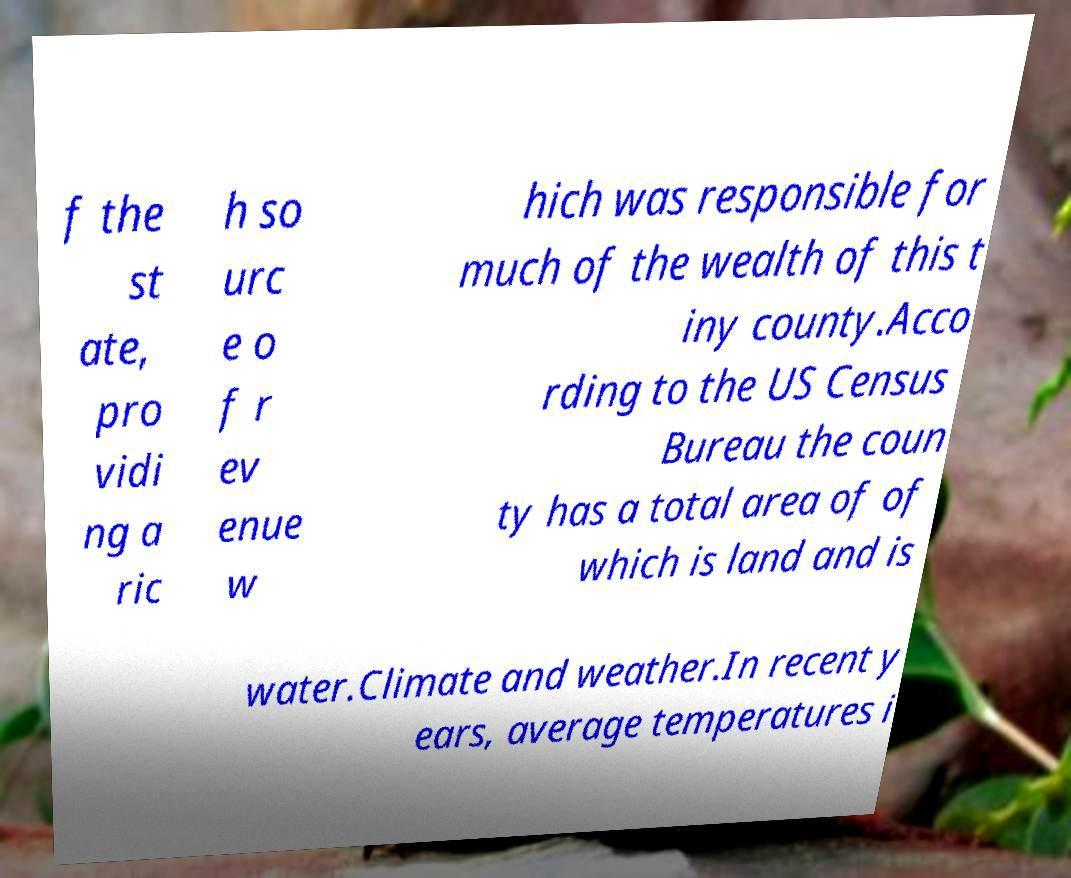There's text embedded in this image that I need extracted. Can you transcribe it verbatim? f the st ate, pro vidi ng a ric h so urc e o f r ev enue w hich was responsible for much of the wealth of this t iny county.Acco rding to the US Census Bureau the coun ty has a total area of of which is land and is water.Climate and weather.In recent y ears, average temperatures i 